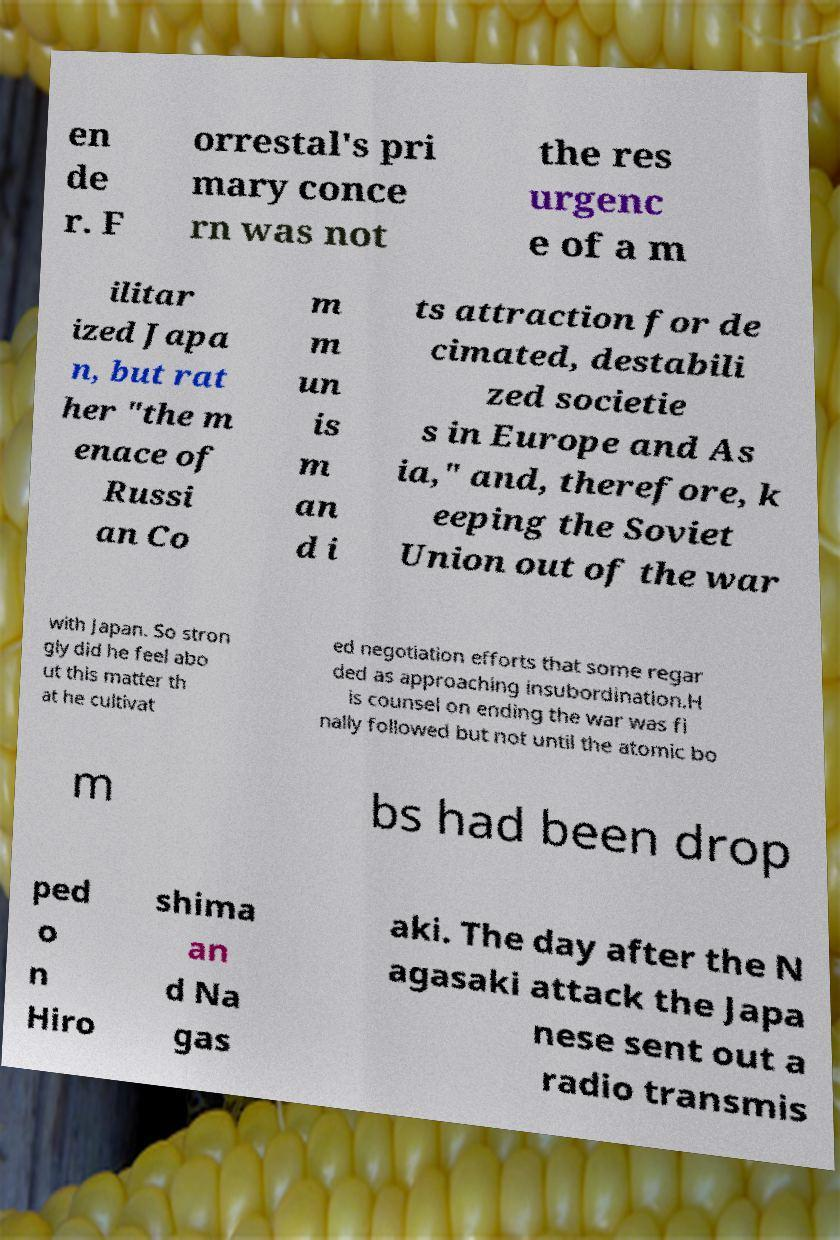Could you assist in decoding the text presented in this image and type it out clearly? en de r. F orrestal's pri mary conce rn was not the res urgenc e of a m ilitar ized Japa n, but rat her "the m enace of Russi an Co m m un is m an d i ts attraction for de cimated, destabili zed societie s in Europe and As ia," and, therefore, k eeping the Soviet Union out of the war with Japan. So stron gly did he feel abo ut this matter th at he cultivat ed negotiation efforts that some regar ded as approaching insubordination.H is counsel on ending the war was fi nally followed but not until the atomic bo m bs had been drop ped o n Hiro shima an d Na gas aki. The day after the N agasaki attack the Japa nese sent out a radio transmis 